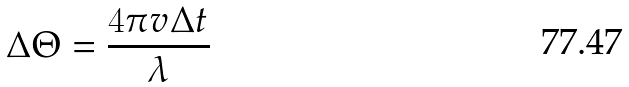<formula> <loc_0><loc_0><loc_500><loc_500>\Delta \Theta = \frac { 4 \pi v \Delta t } { \lambda }</formula> 